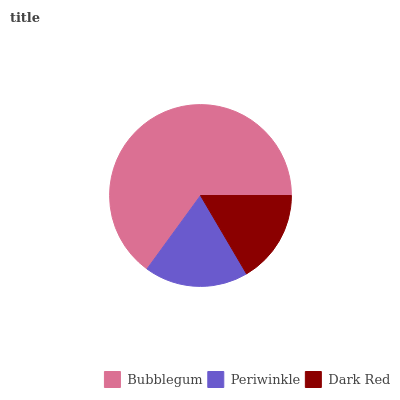Is Dark Red the minimum?
Answer yes or no. Yes. Is Bubblegum the maximum?
Answer yes or no. Yes. Is Periwinkle the minimum?
Answer yes or no. No. Is Periwinkle the maximum?
Answer yes or no. No. Is Bubblegum greater than Periwinkle?
Answer yes or no. Yes. Is Periwinkle less than Bubblegum?
Answer yes or no. Yes. Is Periwinkle greater than Bubblegum?
Answer yes or no. No. Is Bubblegum less than Periwinkle?
Answer yes or no. No. Is Periwinkle the high median?
Answer yes or no. Yes. Is Periwinkle the low median?
Answer yes or no. Yes. Is Bubblegum the high median?
Answer yes or no. No. Is Bubblegum the low median?
Answer yes or no. No. 